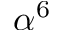Convert formula to latex. <formula><loc_0><loc_0><loc_500><loc_500>\alpha ^ { 6 }</formula> 